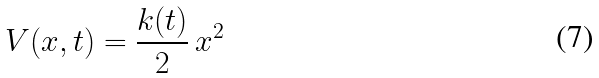<formula> <loc_0><loc_0><loc_500><loc_500>V ( x , t ) = \frac { k ( t ) } { 2 } \, x ^ { 2 }</formula> 